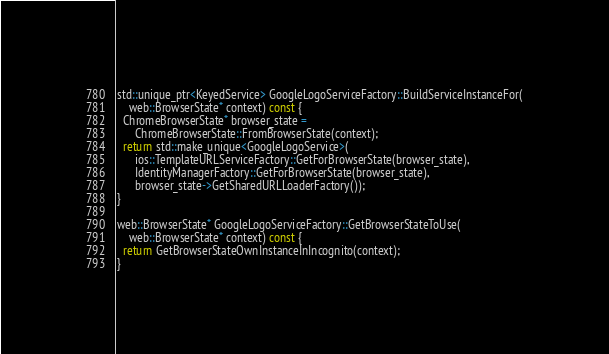<code> <loc_0><loc_0><loc_500><loc_500><_ObjectiveC_>
std::unique_ptr<KeyedService> GoogleLogoServiceFactory::BuildServiceInstanceFor(
    web::BrowserState* context) const {
  ChromeBrowserState* browser_state =
      ChromeBrowserState::FromBrowserState(context);
  return std::make_unique<GoogleLogoService>(
      ios::TemplateURLServiceFactory::GetForBrowserState(browser_state),
      IdentityManagerFactory::GetForBrowserState(browser_state),
      browser_state->GetSharedURLLoaderFactory());
}

web::BrowserState* GoogleLogoServiceFactory::GetBrowserStateToUse(
    web::BrowserState* context) const {
  return GetBrowserStateOwnInstanceInIncognito(context);
}
</code> 